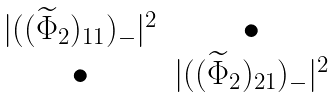Convert formula to latex. <formula><loc_0><loc_0><loc_500><loc_500>\begin{matrix} | ( ( \widetilde { \Phi } _ { 2 } ) _ { 1 1 } ) _ { - } | ^ { 2 } & \bullet \\ \bullet & | ( ( \widetilde { \Phi } _ { 2 } ) _ { 2 1 } ) _ { - } | ^ { 2 } \\ \end{matrix}</formula> 